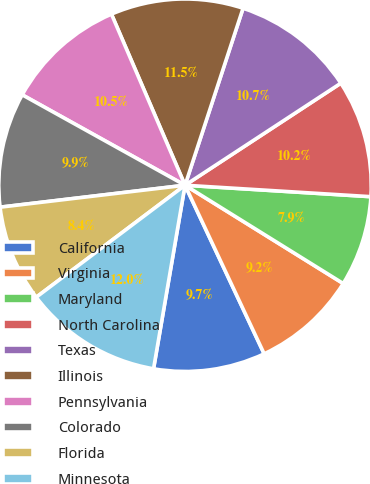Convert chart. <chart><loc_0><loc_0><loc_500><loc_500><pie_chart><fcel>California<fcel>Virginia<fcel>Maryland<fcel>North Carolina<fcel>Texas<fcel>Illinois<fcel>Pennsylvania<fcel>Colorado<fcel>Florida<fcel>Minnesota<nl><fcel>9.69%<fcel>9.17%<fcel>7.87%<fcel>10.21%<fcel>10.73%<fcel>11.51%<fcel>10.47%<fcel>9.95%<fcel>8.39%<fcel>12.03%<nl></chart> 